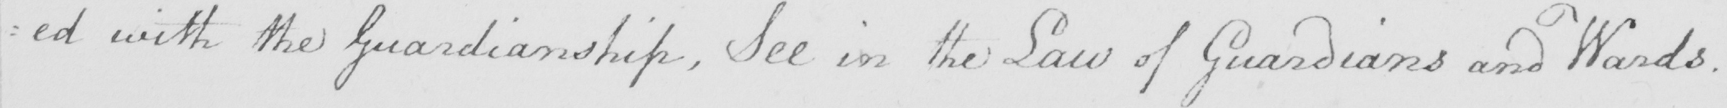What text is written in this handwritten line? : ed with the Guardianship , See in the Law of Guardians and Wards . 